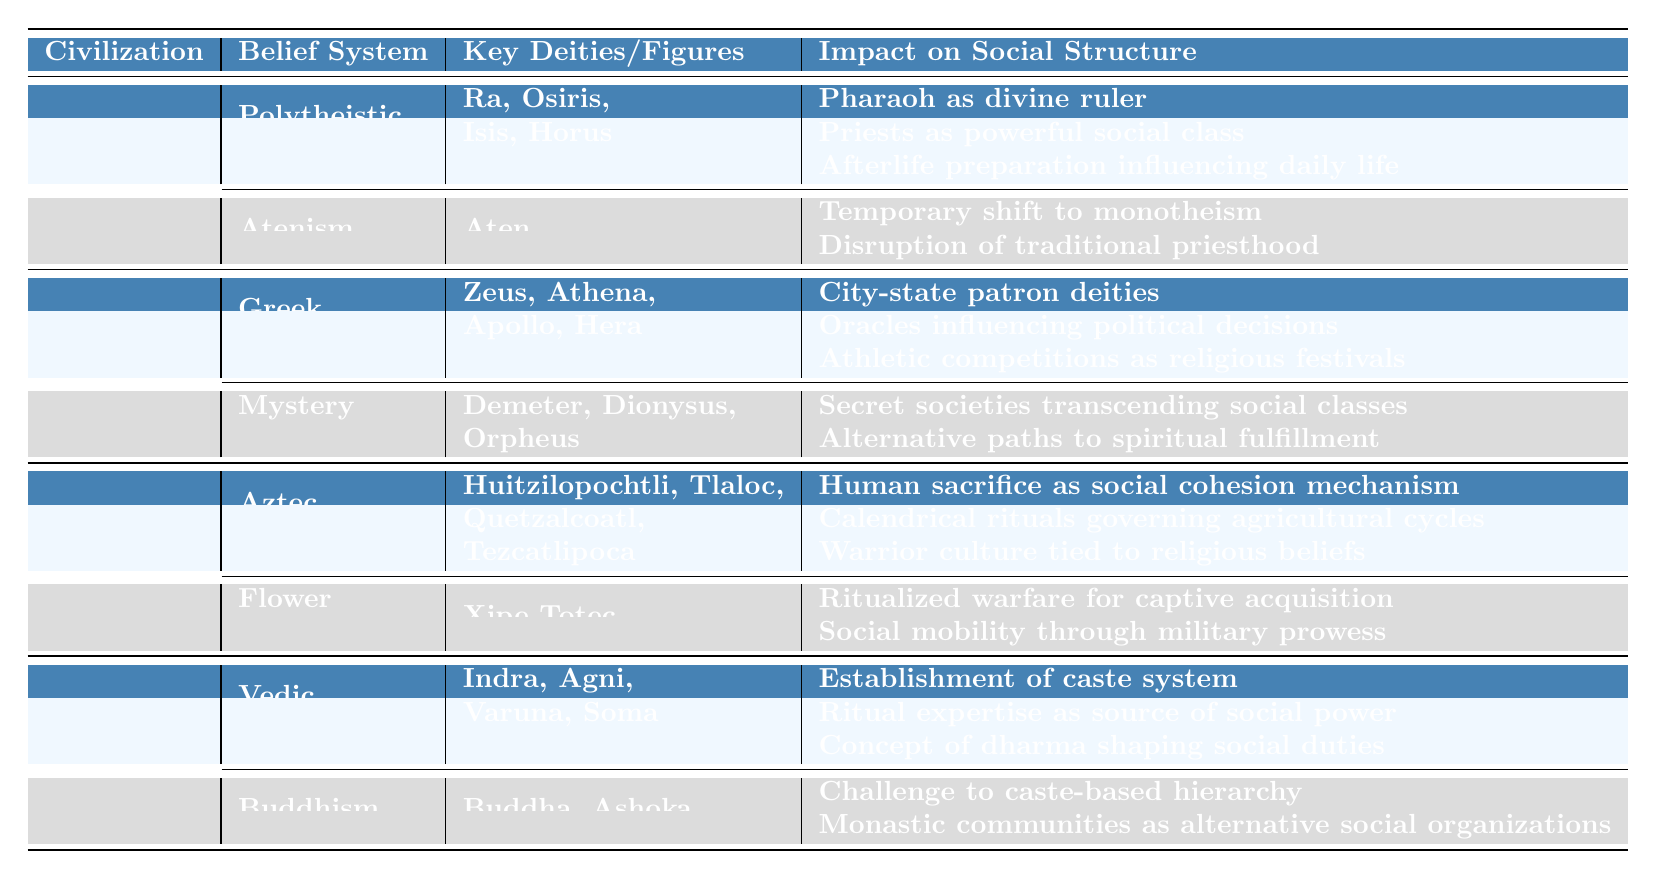What are the key deities in Ancient Egypt's Polytheistic Religion? The table lists Ra, Osiris, Isis, and Horus as the key deities of Ancient Egypt's Polytheistic Religion.
Answer: Ra, Osiris, Isis, Horus Which belief system in Ancient Greece involved secret societies? The table indicates that "Mystery Cults" is the belief system associated with secret societies in Ancient Greece.
Answer: Mystery Cults What impact did Atenism have on the social structure? Atenism led to a temporary shift to monotheism, disrupted the traditional priesthood, and centralization of power in the royal family, according to the table.
Answer: Disrupted traditional priesthood and centralized power Did Ancient Greece have a belief system that incorporated athletic competitions? Yes, Greek Mythology included athletic competitions as religious festivals, as shown in the table.
Answer: Yes Which civilization established a caste system? The table states that the Vedic Religion in Ancient India established a caste system, answering the question directly.
Answer: Ancient India What was the primary social cohesion mechanism in the Aztec Empire? Human sacrifice is described in the table as the social cohesion mechanism in Aztec Religion.
Answer: Human sacrifice How many belief systems are listed for Ancient India? The table shows that Ancient India has two belief systems, Vedic Religion and Buddhism.
Answer: Two What were the challenges posed by Buddhism to social structure in Ancient India? Buddhism challenged the caste-based hierarchy, established monastic communities, and spread ethical principles, as per the table.
Answer: Caste-based hierarchy Which civilization's belief system involves the influence of oracles on political decisions? According to the table, Ancient Greece's Greek Mythology involved oracles influencing political decisions.
Answer: Ancient Greece Compare the impacts of Vedic Religion and Buddhism on social structure in Ancient India. Vedic Religion established the caste system, while Buddhism challenged this hierarchy and provided alternative social organizations, highlighting a contrast in impacts.
Answer: Vedic Religion established caste; Buddhism challenged it How is warrior culture related to the Aztec belief system? The table indicates that the warrior culture was tied to religious beliefs in the context of Aztec Religion, specifically implying a close relationship.
Answer: Tied to religious beliefs What unconventional research area is associated with the Aztec Empire? The table lists psychoactive substances in religious rituals as an unconventional research area associated with the Aztec Empire.
Answer: Psychoactive substances in rituals Did Ancient Egypt's social structure include priests as a powerful class in the Polytheistic Religion? Yes, the table confirms that priests were a powerful social class in the social structure of Ancient Egypt's Polytheistic Religion.
Answer: Yes What does the influence of Nile flooding on religious practices pertain to in Ancient Egypt? This unconventional research area suggests a relationship between environmental factors and religious practices, highlighting the unique integration of nature and belief.
Answer: Environmental influence on practices 